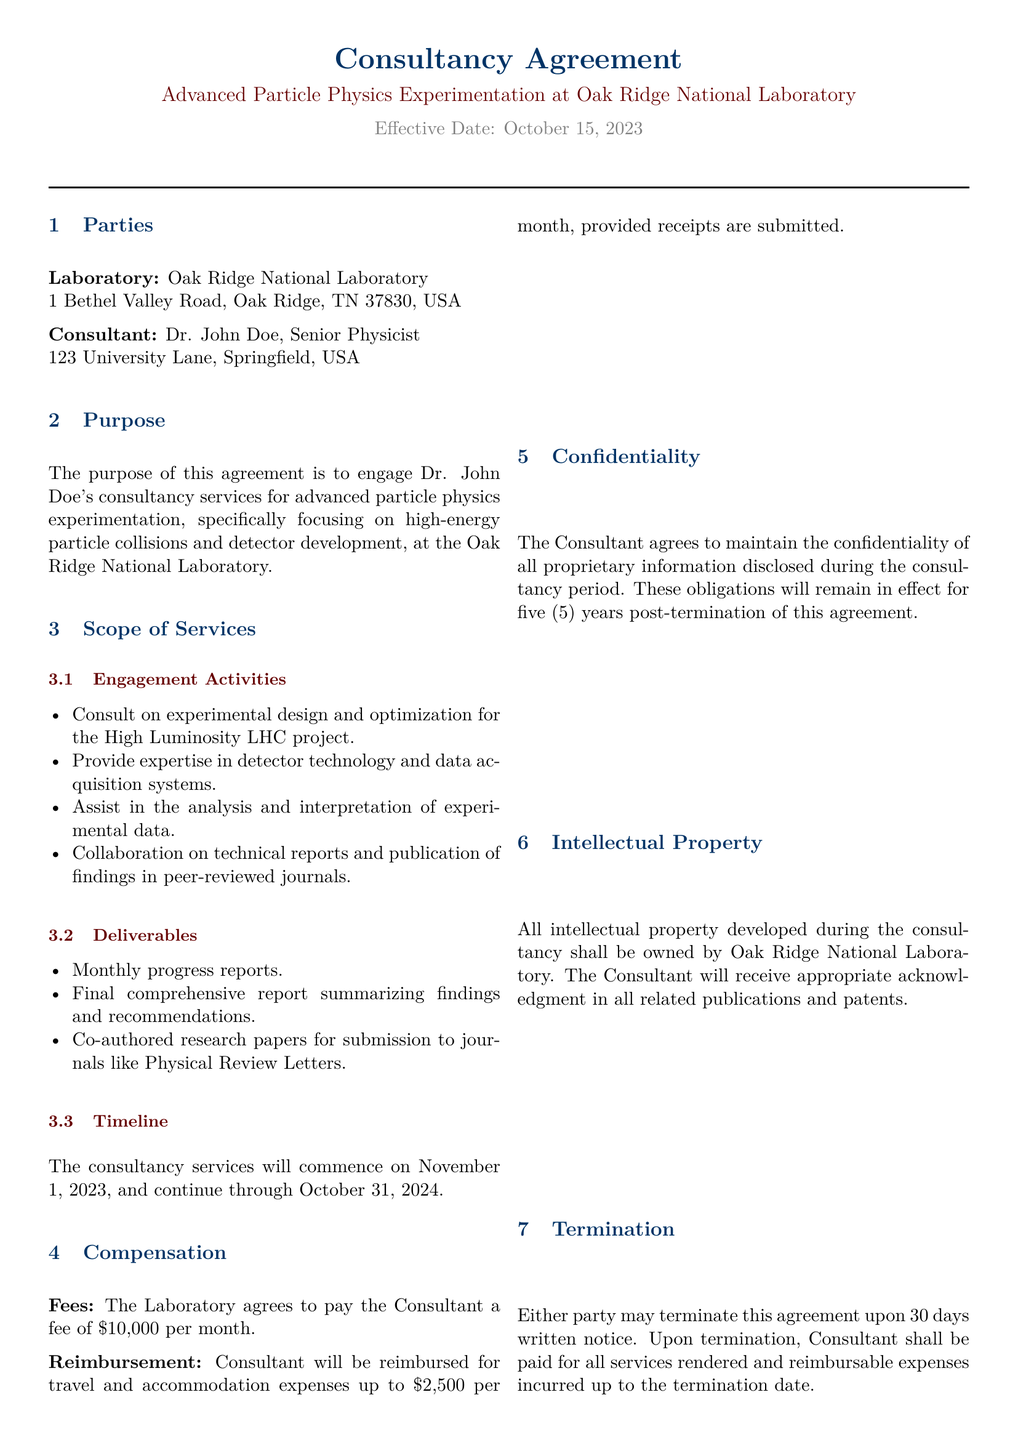What is the effective date of the agreement? The effective date is specified in the document.
Answer: October 15, 2023 Who is the consultant? The consultant's name and title are clearly stated in the document.
Answer: Dr. John Doe, Senior Physicist What is the monthly fee for the consultant's services? The fee is stated under the compensation section of the document.
Answer: $10,000 How long will the consultancy services last? The timeline for the consultancy services is provided in the document.
Answer: November 1, 2023, to October 31, 2024 What will the consultant be reimbursed for? The document specifies what expenses are eligible for reimbursement.
Answer: Travel and accommodation expenses What is the duration of the confidentiality obligation after termination? The confidentiality section mentions how long these obligations last.
Answer: Five years What type of agreement is this document? The title of the document indicates its type.
Answer: Consultancy Agreement What must the consultant provide as a deliverable each month? A specific type of deliverable is mentioned under the deliverables section.
Answer: Monthly progress reports Who will own the intellectual property developed during the consultancy? The intellectual property section specifies ownership of developed IP.
Answer: Oak Ridge National Laboratory 